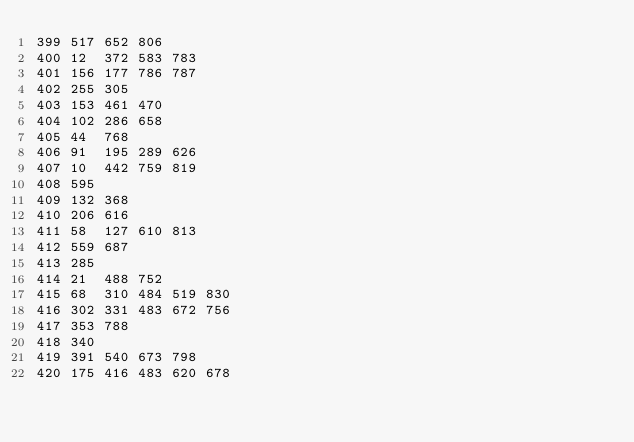<code> <loc_0><loc_0><loc_500><loc_500><_Perl_>399	517	652	806
400	12	372	583	783
401	156	177	786	787
402	255	305
403	153	461	470
404	102	286	658
405	44	768
406	91	195	289	626
407	10	442	759	819
408	595
409	132	368
410	206	616
411	58	127	610	813
412	559	687
413	285
414	21	488	752
415	68	310	484	519	830
416	302	331	483	672	756
417	353	788
418	340
419	391	540	673	798
420	175	416	483	620	678</code> 